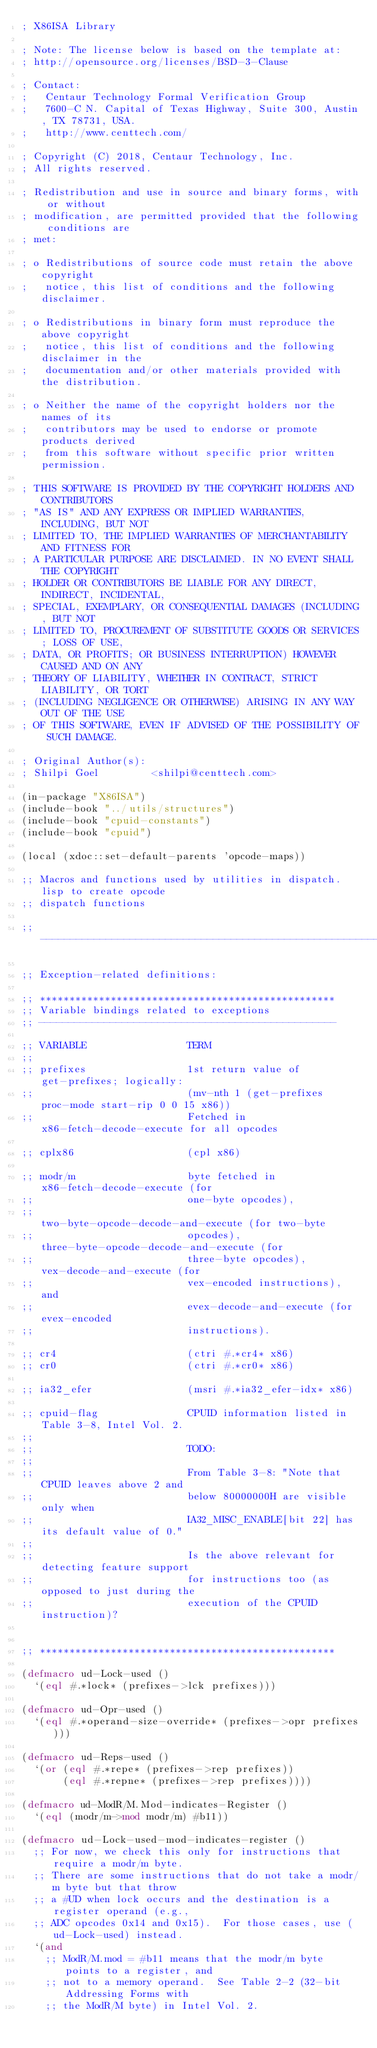<code> <loc_0><loc_0><loc_500><loc_500><_Lisp_>; X86ISA Library

; Note: The license below is based on the template at:
; http://opensource.org/licenses/BSD-3-Clause

; Contact:
;   Centaur Technology Formal Verification Group
;   7600-C N. Capital of Texas Highway, Suite 300, Austin, TX 78731, USA.
;   http://www.centtech.com/

; Copyright (C) 2018, Centaur Technology, Inc.
; All rights reserved.

; Redistribution and use in source and binary forms, with or without
; modification, are permitted provided that the following conditions are
; met:

; o Redistributions of source code must retain the above copyright
;   notice, this list of conditions and the following disclaimer.

; o Redistributions in binary form must reproduce the above copyright
;   notice, this list of conditions and the following disclaimer in the
;   documentation and/or other materials provided with the distribution.

; o Neither the name of the copyright holders nor the names of its
;   contributors may be used to endorse or promote products derived
;   from this software without specific prior written permission.

; THIS SOFTWARE IS PROVIDED BY THE COPYRIGHT HOLDERS AND CONTRIBUTORS
; "AS IS" AND ANY EXPRESS OR IMPLIED WARRANTIES, INCLUDING, BUT NOT
; LIMITED TO, THE IMPLIED WARRANTIES OF MERCHANTABILITY AND FITNESS FOR
; A PARTICULAR PURPOSE ARE DISCLAIMED. IN NO EVENT SHALL THE COPYRIGHT
; HOLDER OR CONTRIBUTORS BE LIABLE FOR ANY DIRECT, INDIRECT, INCIDENTAL,
; SPECIAL, EXEMPLARY, OR CONSEQUENTIAL DAMAGES (INCLUDING, BUT NOT
; LIMITED TO, PROCUREMENT OF SUBSTITUTE GOODS OR SERVICES; LOSS OF USE,
; DATA, OR PROFITS; OR BUSINESS INTERRUPTION) HOWEVER CAUSED AND ON ANY
; THEORY OF LIABILITY, WHETHER IN CONTRACT, STRICT LIABILITY, OR TORT
; (INCLUDING NEGLIGENCE OR OTHERWISE) ARISING IN ANY WAY OUT OF THE USE
; OF THIS SOFTWARE, EVEN IF ADVISED OF THE POSSIBILITY OF SUCH DAMAGE.

; Original Author(s):
; Shilpi Goel         <shilpi@centtech.com>

(in-package "X86ISA")
(include-book "../utils/structures")
(include-book "cpuid-constants")
(include-book "cpuid")

(local (xdoc::set-default-parents 'opcode-maps))

;; Macros and functions used by utilities in dispatch.lisp to create opcode
;; dispatch functions

;; ----------------------------------------------------------------------

;; Exception-related definitions:

;; **************************************************
;; Variable bindings related to exceptions
;; --------------------------------------------------

;; VARIABLE                 TERM
;;
;; prefixes                 1st return value of get-prefixes; logically:
;;                          (mv-nth 1 (get-prefixes proc-mode start-rip 0 0 15 x86))
;;                          Fetched in x86-fetch-decode-execute for all opcodes

;; cplx86                   (cpl x86)

;; modr/m                   byte fetched in x86-fetch-decode-execute (for
;;                          one-byte opcodes),
;;                          two-byte-opcode-decode-and-execute (for two-byte
;;                          opcodes), three-byte-opcode-decode-and-execute (for
;;                          three-byte opcodes), vex-decode-and-execute (for
;;                          vex-encoded instructions), and
;;                          evex-decode-and-execute (for evex-encoded
;;                          instructions).

;; cr4                      (ctri #.*cr4* x86)
;; cr0                      (ctri #.*cr0* x86)

;; ia32_efer                (msri #.*ia32_efer-idx* x86)

;; cpuid-flag               CPUID information listed in Table 3-8, Intel Vol. 2.
;;
;;                          TODO:
;;
;;                          From Table 3-8: "Note that CPUID leaves above 2 and
;;                          below 80000000H are visible only when
;;                          IA32_MISC_ENABLE[bit 22] has its default value of 0."
;;
;;                          Is the above relevant for detecting feature support
;;                          for instructions too (as opposed to just during the
;;                          execution of the CPUID instruction)?


;; **************************************************

(defmacro ud-Lock-used ()
  `(eql #.*lock* (prefixes->lck prefixes)))

(defmacro ud-Opr-used ()
  `(eql #.*operand-size-override* (prefixes->opr prefixes)))

(defmacro ud-Reps-used ()
  `(or (eql #.*repe* (prefixes->rep prefixes))
       (eql #.*repne* (prefixes->rep prefixes))))

(defmacro ud-ModR/M.Mod-indicates-Register ()
  `(eql (modr/m->mod modr/m) #b11))

(defmacro ud-Lock-used-mod-indicates-register ()
  ;; For now, we check this only for instructions that require a modr/m byte.
  ;; There are some instructions that do not take a modr/m byte but that throw
  ;; a #UD when lock occurs and the destination is a register operand (e.g.,
  ;; ADC opcodes 0x14 and 0x15).  For those cases, use (ud-Lock-used) instead.
  `(and
    ;; ModR/M.mod = #b11 means that the modr/m byte points to a register, and
    ;; not to a memory operand.  See Table 2-2 (32-bit Addressing Forms with
    ;; the ModR/M byte) in Intel Vol. 2.</code> 